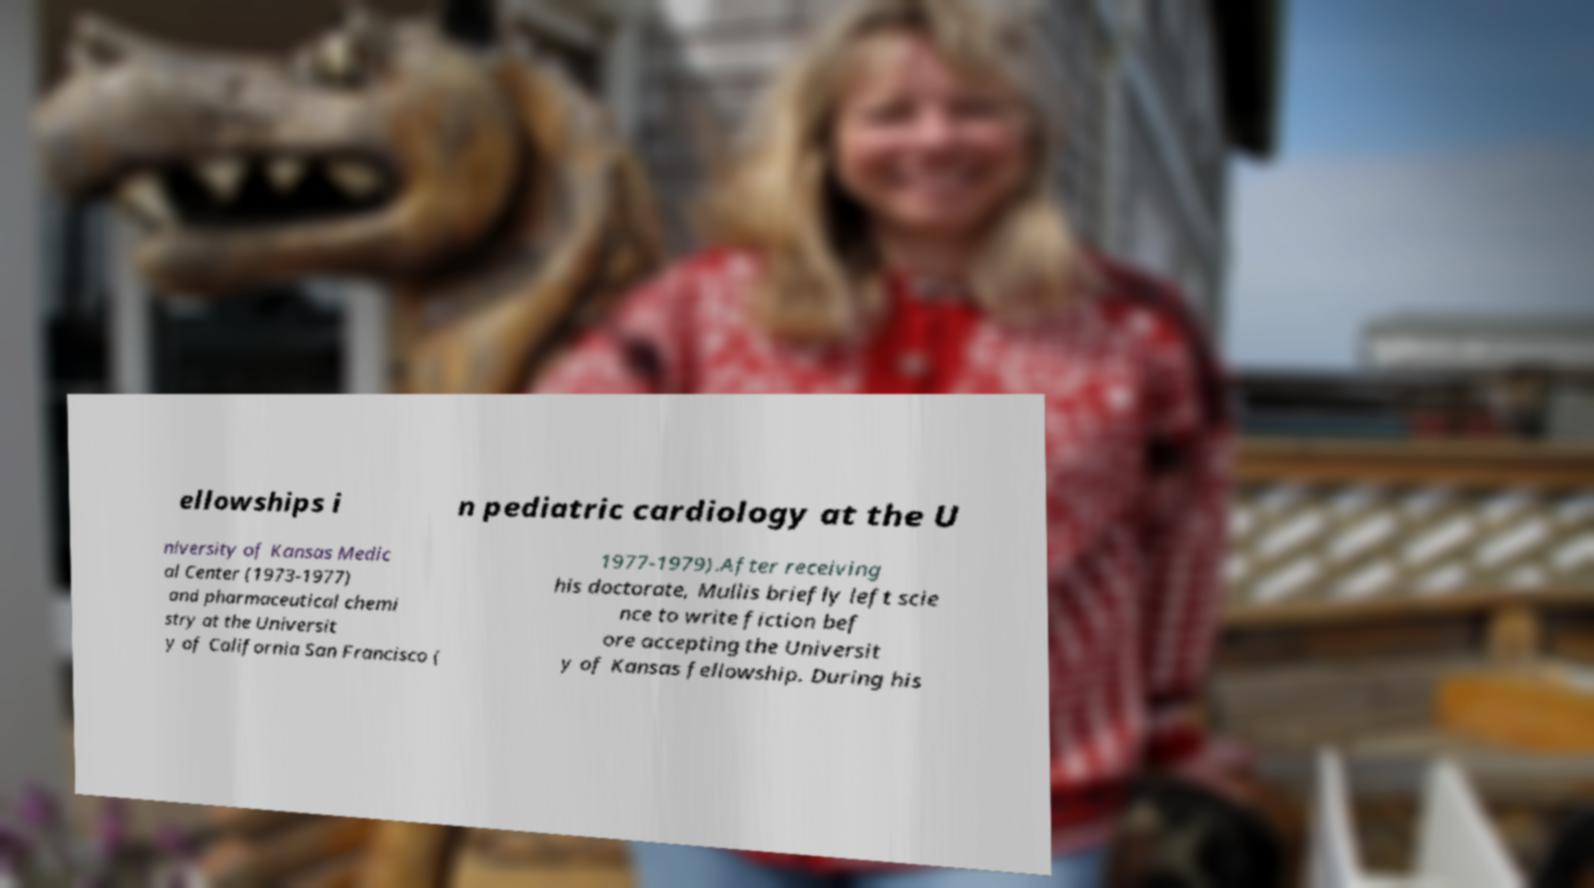Can you read and provide the text displayed in the image?This photo seems to have some interesting text. Can you extract and type it out for me? ellowships i n pediatric cardiology at the U niversity of Kansas Medic al Center (1973-1977) and pharmaceutical chemi stry at the Universit y of California San Francisco ( 1977-1979).After receiving his doctorate, Mullis briefly left scie nce to write fiction bef ore accepting the Universit y of Kansas fellowship. During his 